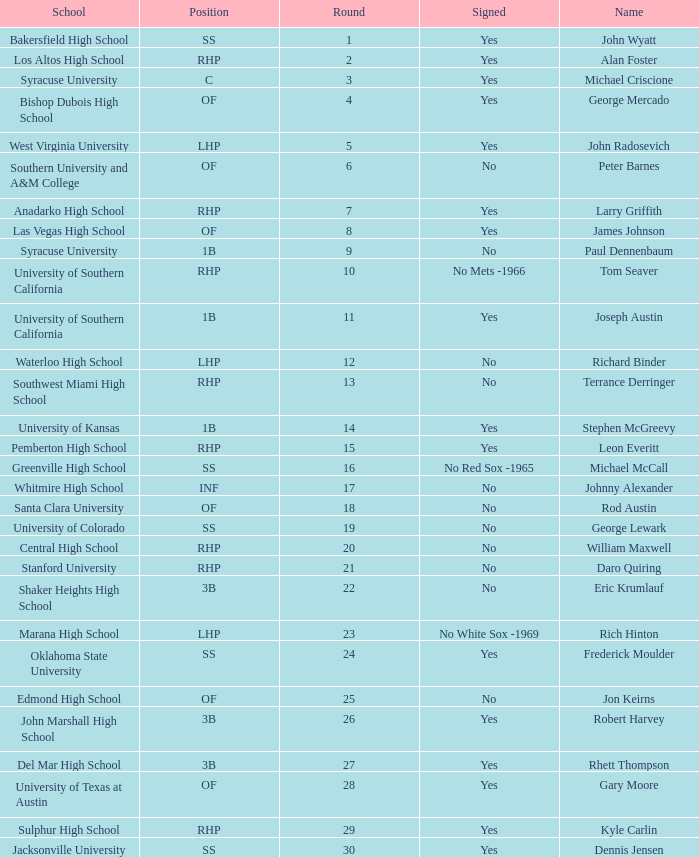What is the name of the player taken in round 23? Rich Hinton. 